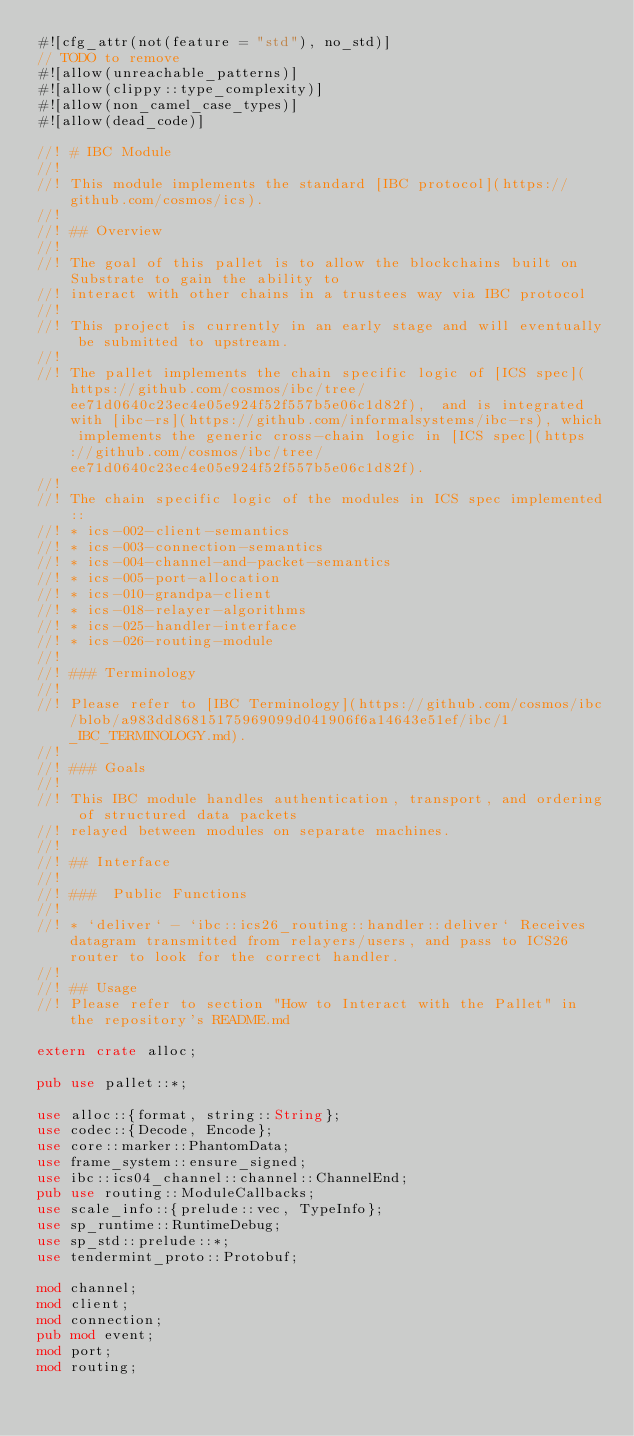<code> <loc_0><loc_0><loc_500><loc_500><_Rust_>#![cfg_attr(not(feature = "std"), no_std)]
// TODO to remove
#![allow(unreachable_patterns)]
#![allow(clippy::type_complexity)]
#![allow(non_camel_case_types)]
#![allow(dead_code)]

//! # IBC Module
//!
//! This module implements the standard [IBC protocol](https://github.com/cosmos/ics).
//!
//! ## Overview
//!
//! The goal of this pallet is to allow the blockchains built on Substrate to gain the ability to
//! interact with other chains in a trustees way via IBC protocol
//!
//! This project is currently in an early stage and will eventually be submitted to upstream.
//!
//! The pallet implements the chain specific logic of [ICS spec](https://github.com/cosmos/ibc/tree/ee71d0640c23ec4e05e924f52f557b5e06c1d82f),  and is integrated with [ibc-rs](https://github.com/informalsystems/ibc-rs), which implements the generic cross-chain logic in [ICS spec](https://github.com/cosmos/ibc/tree/ee71d0640c23ec4e05e924f52f557b5e06c1d82f).
//!
//! The chain specific logic of the modules in ICS spec implemented::
//! * ics-002-client-semantics
//! * ics-003-connection-semantics
//! * ics-004-channel-and-packet-semantics
//! * ics-005-port-allocation
//! * ics-010-grandpa-client
//! * ics-018-relayer-algorithms
//! * ics-025-handler-interface
//! * ics-026-routing-module
//!
//! ### Terminology
//!
//! Please refer to [IBC Terminology](https://github.com/cosmos/ibc/blob/a983dd86815175969099d041906f6a14643e51ef/ibc/1_IBC_TERMINOLOGY.md).
//!
//! ### Goals
//!
//! This IBC module handles authentication, transport, and ordering of structured data packets
//! relayed between modules on separate machines.
//!
//! ## Interface
//!
//! ###  Public Functions
//!
//! * `deliver` - `ibc::ics26_routing::handler::deliver` Receives datagram transmitted from relayers/users, and pass to ICS26 router to look for the correct handler.
//!
//! ## Usage
//! Please refer to section "How to Interact with the Pallet" in the repository's README.md

extern crate alloc;

pub use pallet::*;

use alloc::{format, string::String};
use codec::{Decode, Encode};
use core::marker::PhantomData;
use frame_system::ensure_signed;
use ibc::ics04_channel::channel::ChannelEnd;
pub use routing::ModuleCallbacks;
use scale_info::{prelude::vec, TypeInfo};
use sp_runtime::RuntimeDebug;
use sp_std::prelude::*;
use tendermint_proto::Protobuf;

mod channel;
mod client;
mod connection;
pub mod event;
mod port;
mod routing;
</code> 